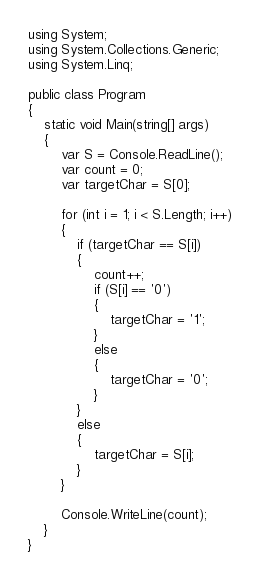<code> <loc_0><loc_0><loc_500><loc_500><_C#_>using System;
using System.Collections.Generic;
using System.Linq;

public class Program
{
	static void Main(string[] args)
	{
		var S = Console.ReadLine();
		var count = 0;
		var targetChar = S[0];

		for (int i = 1; i < S.Length; i++)
		{
			if (targetChar == S[i])
			{
				count++;
				if (S[i] == '0')
				{
					targetChar = '1';
				}
				else
				{
					targetChar = '0';
				}
			}
			else
			{
				targetChar = S[i];
			}
		}

		Console.WriteLine(count);
	}
}
</code> 